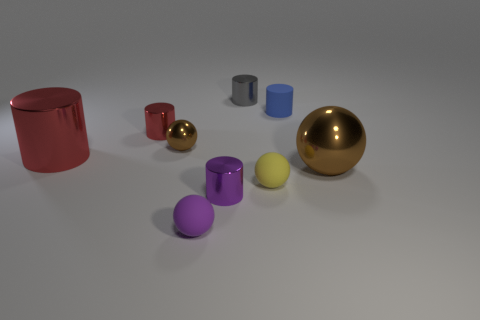Subtract 1 spheres. How many spheres are left? 3 Subtract all cyan cylinders. Subtract all red blocks. How many cylinders are left? 5 Subtract all cylinders. How many objects are left? 4 Add 3 tiny metallic balls. How many tiny metallic balls exist? 4 Subtract 0 brown cubes. How many objects are left? 9 Subtract all small gray matte balls. Subtract all big brown things. How many objects are left? 8 Add 7 purple matte objects. How many purple matte objects are left? 8 